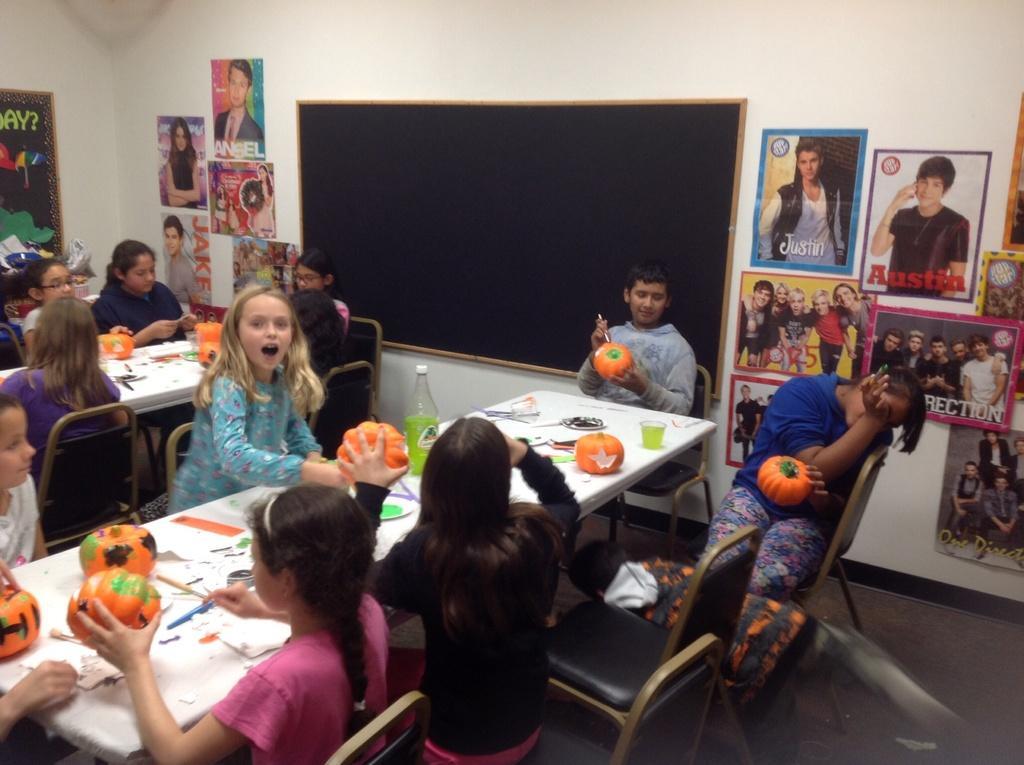Please provide a concise description of this image. In this picture there are several kids painting a pumpkin and there are many posters ,black board attached to the wall. 